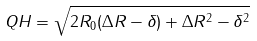Convert formula to latex. <formula><loc_0><loc_0><loc_500><loc_500>Q H = \sqrt { 2 R _ { 0 } ( \Delta R - \delta ) + \Delta R ^ { 2 } - \delta ^ { 2 } }</formula> 